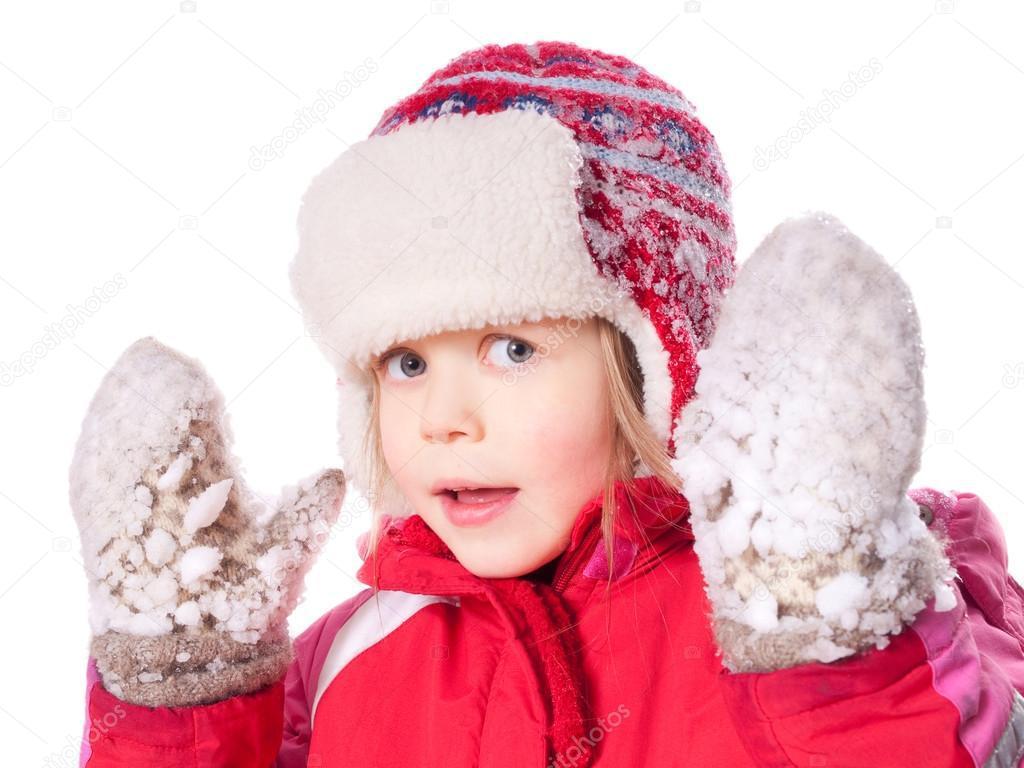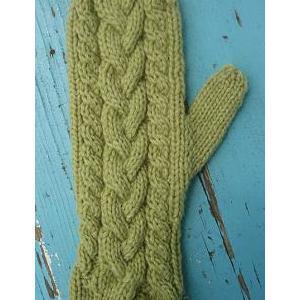The first image is the image on the left, the second image is the image on the right. Given the left and right images, does the statement "You can see someone's eyes in every single image." hold true? Answer yes or no. No. 